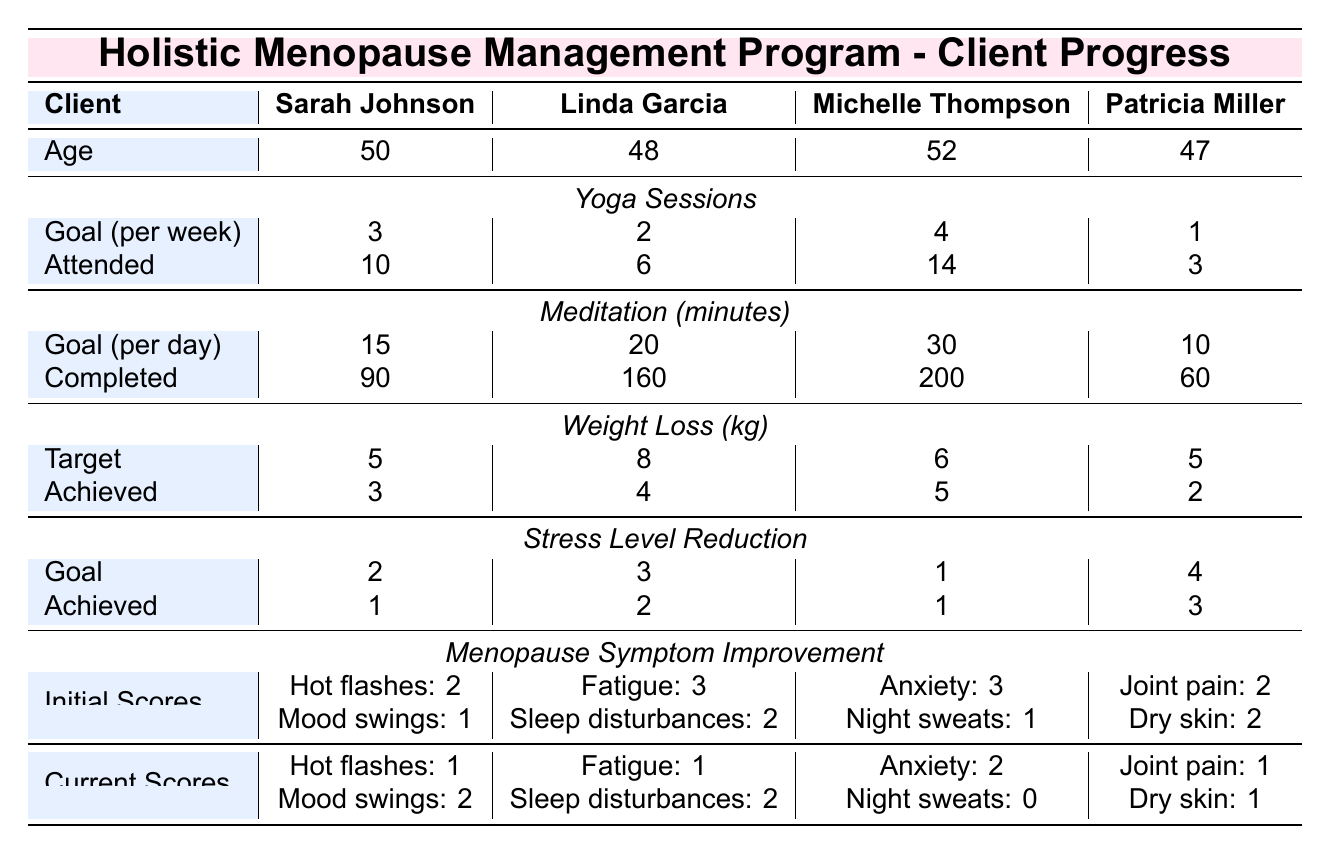What is the weight loss target for Linda Garcia? From the table, under Linda Garcia's section, the weight loss target is specified in the "Weight Loss (kg)" category. The target listed is 8 kg.
Answer: 8 kg How many yoga sessions did Michelle Thompson attend? The table shows Michelle Thompson's attendance under the "Yoga Sessions" category. The number of yoga sessions attended is listed as 14.
Answer: 14 What is the difference between the stress level reduction goal and the achieved level for Sarah Johnson? For Sarah Johnson, the stress level reduction goal is 2 and the achieved level is 1. The difference is calculated as 2 - 1, which equals 1.
Answer: 1 Who achieved the most weight loss? The weight loss achieved for each client is compared: Sarah Johnson (3 kg), Linda Garcia (4 kg), Michelle Thompson (5 kg), and Patricia Miller (2 kg). Michelle Thompson achieved the highest at 5 kg.
Answer: Michelle Thompson What is the total amount of meditation minutes completed by all clients? The table lists the completed meditation minutes for each client: Sarah Johnson (90), Linda Garcia (160), Michelle Thompson (200), and Patricia Miller (60). Adding these: 90 + 160 + 200 + 60 = 510.
Answer: 510 minutes Did Patricia Miller meet her weight loss target? Patricia Miller's weight loss target is 5 kg, but she achieved only 2 kg as noted in the table. Therefore, she did not meet her target.
Answer: No What is the average weight loss achieved by the clients? The total weight loss achieved by all clients is: 3 + 4 + 5 + 2 = 14 kg. There are 4 clients, so the average is 14 kg / 4 = 3.5 kg.
Answer: 3.5 kg Which client improved the most in terms of menopause symptom scores for sleep disturbances? Linda Garcia had an initial score of 2 for sleep disturbances and now has a score of 2 as well, meaning no improvement. The other clients have either no records for sleep disturbances or improved. Linda Garcia is the only one with a current score equal to the previous score. Thus, she shows no improvement.
Answer: No improvement How many clients had a reduction in their scores for menopause symptoms? From the "Current Scores" section, Sarah, Linda, and Patricia had scores for menopause symptoms that were lower or equal to their initial scores, indicating a reduction. The only exception is Michelle, whose anxiety score improved, but night sweats' score did not drop. Thus, 3 clients had symptom score reductions.
Answer: 3 What is the trend for the yoga sessions attended by clients compared to their goals? Comparing attendance to goals: Sarah Johnson attended 10 (goal of 3), Linda Garcia attended 6 (goal of 2), Michelle Thompson attended 14 (goal of 4), and Patricia Miller attended 3 (goal of 1). All clients exceeded their yoga session goals.
Answer: All exceeded goals 